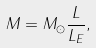Convert formula to latex. <formula><loc_0><loc_0><loc_500><loc_500>M = M _ { \odot } \frac { L } { L _ { E } } ,</formula> 